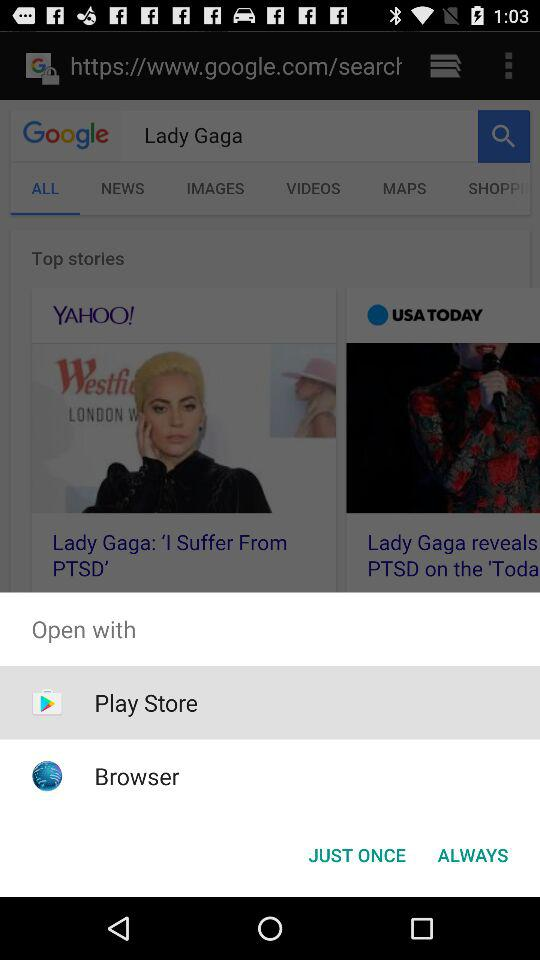When was the article posted on "YAHOO!"?
When the provided information is insufficient, respond with <no answer>. <no answer> 